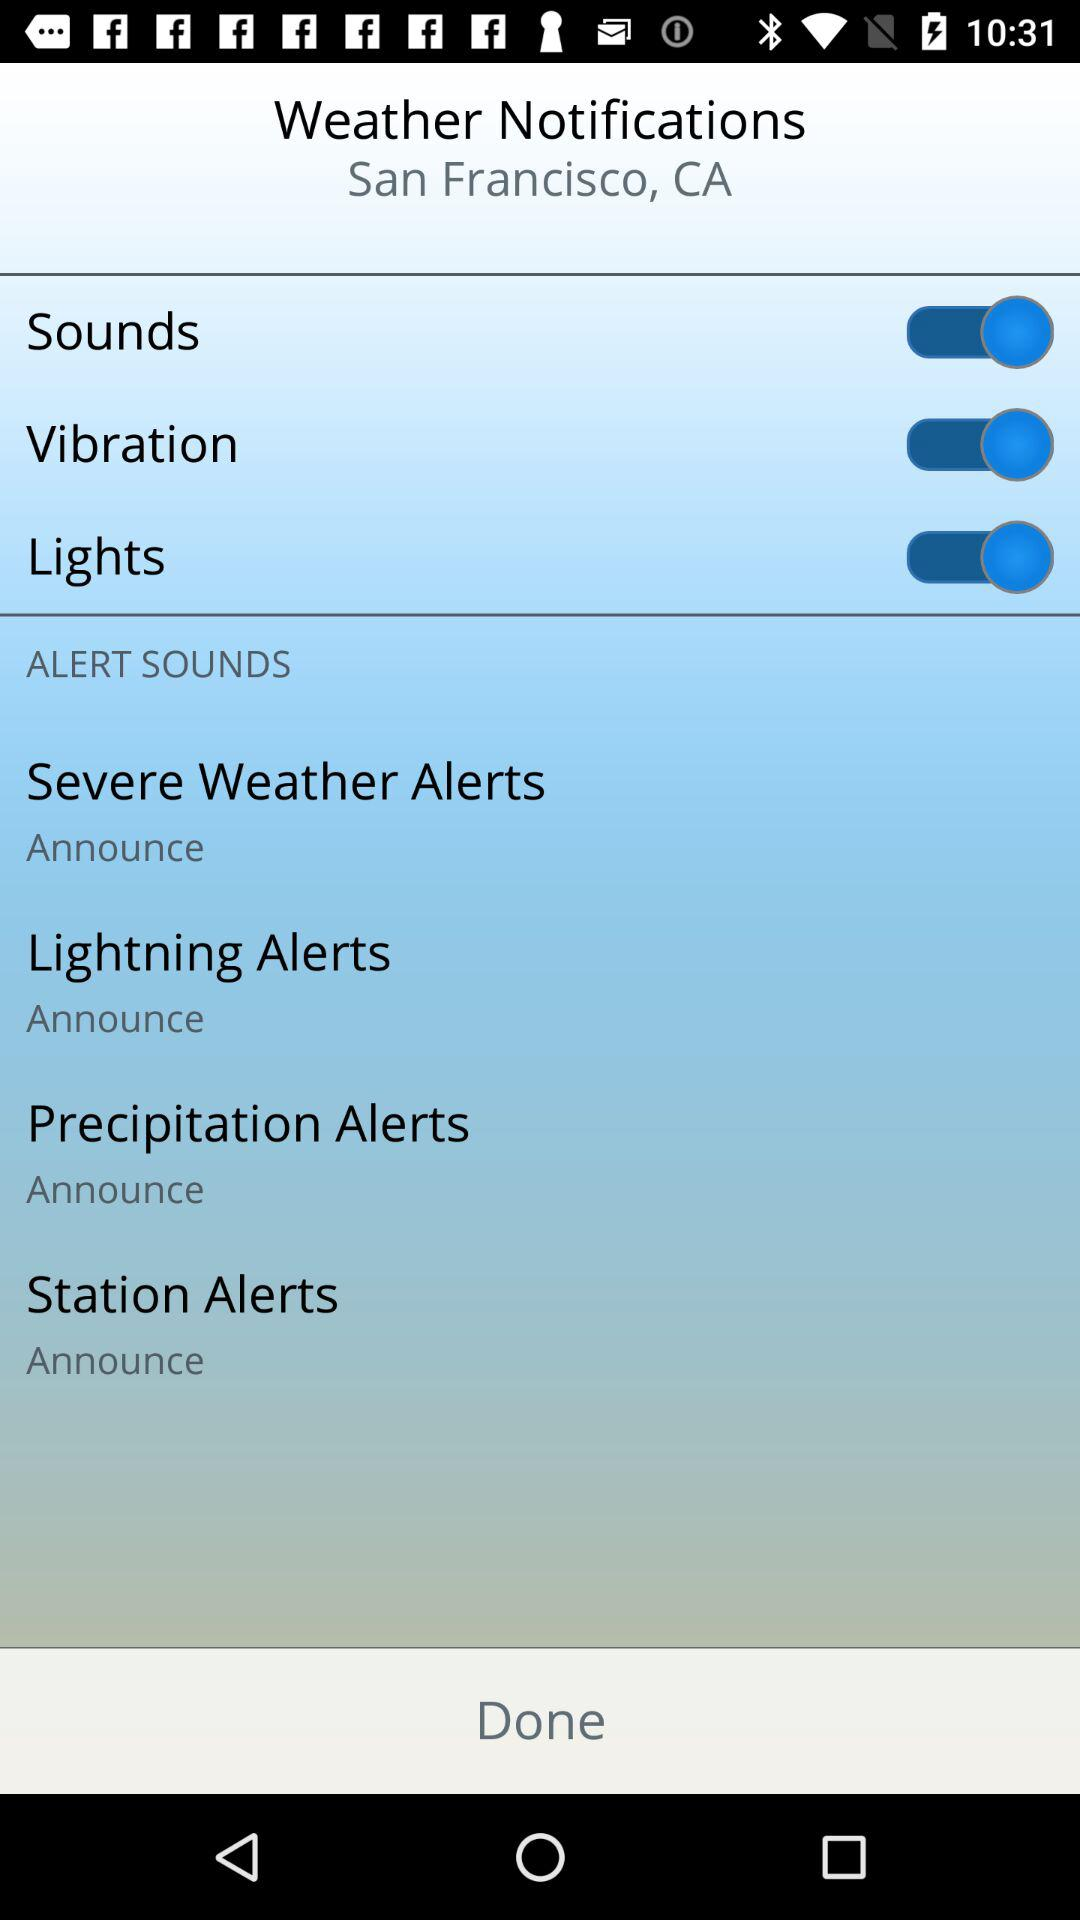What is the given location? The given location is San Francisco, CA. 